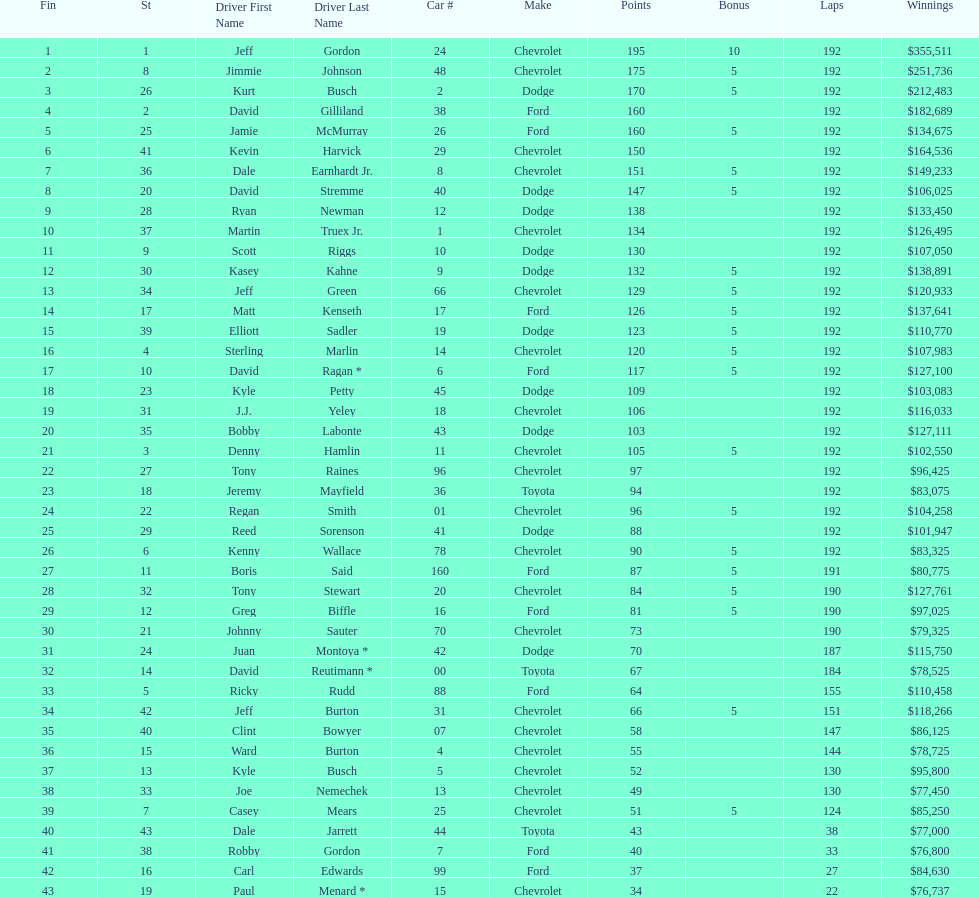How many drivers earned 5 bonus each in the race? 19. 